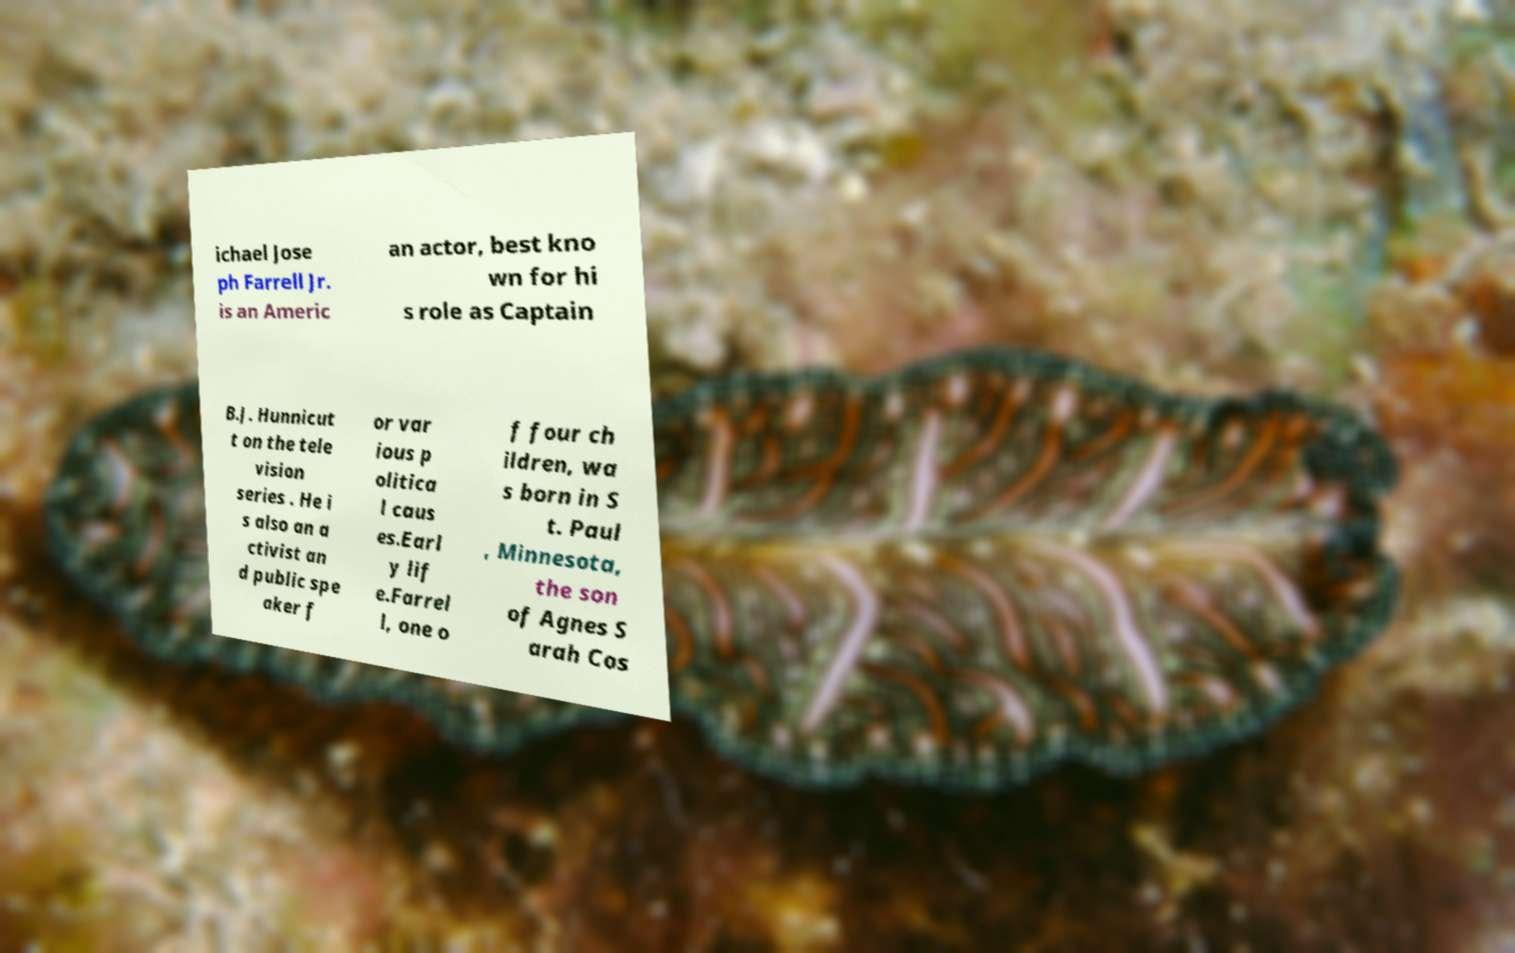Could you assist in decoding the text presented in this image and type it out clearly? ichael Jose ph Farrell Jr. is an Americ an actor, best kno wn for hi s role as Captain B.J. Hunnicut t on the tele vision series . He i s also an a ctivist an d public spe aker f or var ious p olitica l caus es.Earl y lif e.Farrel l, one o f four ch ildren, wa s born in S t. Paul , Minnesota, the son of Agnes S arah Cos 